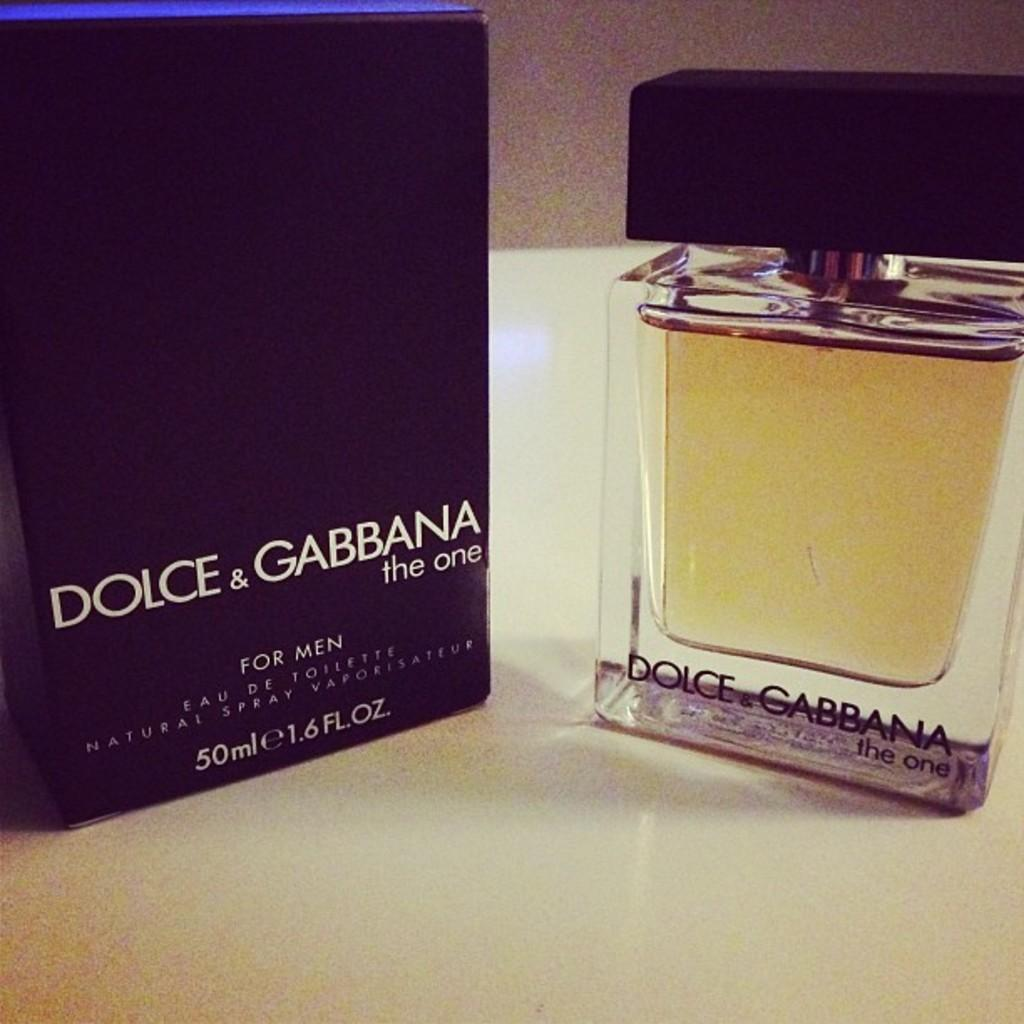<image>
Describe the image concisely. Bottle of perfume next to a box that says "Dolce & Gabbana". 